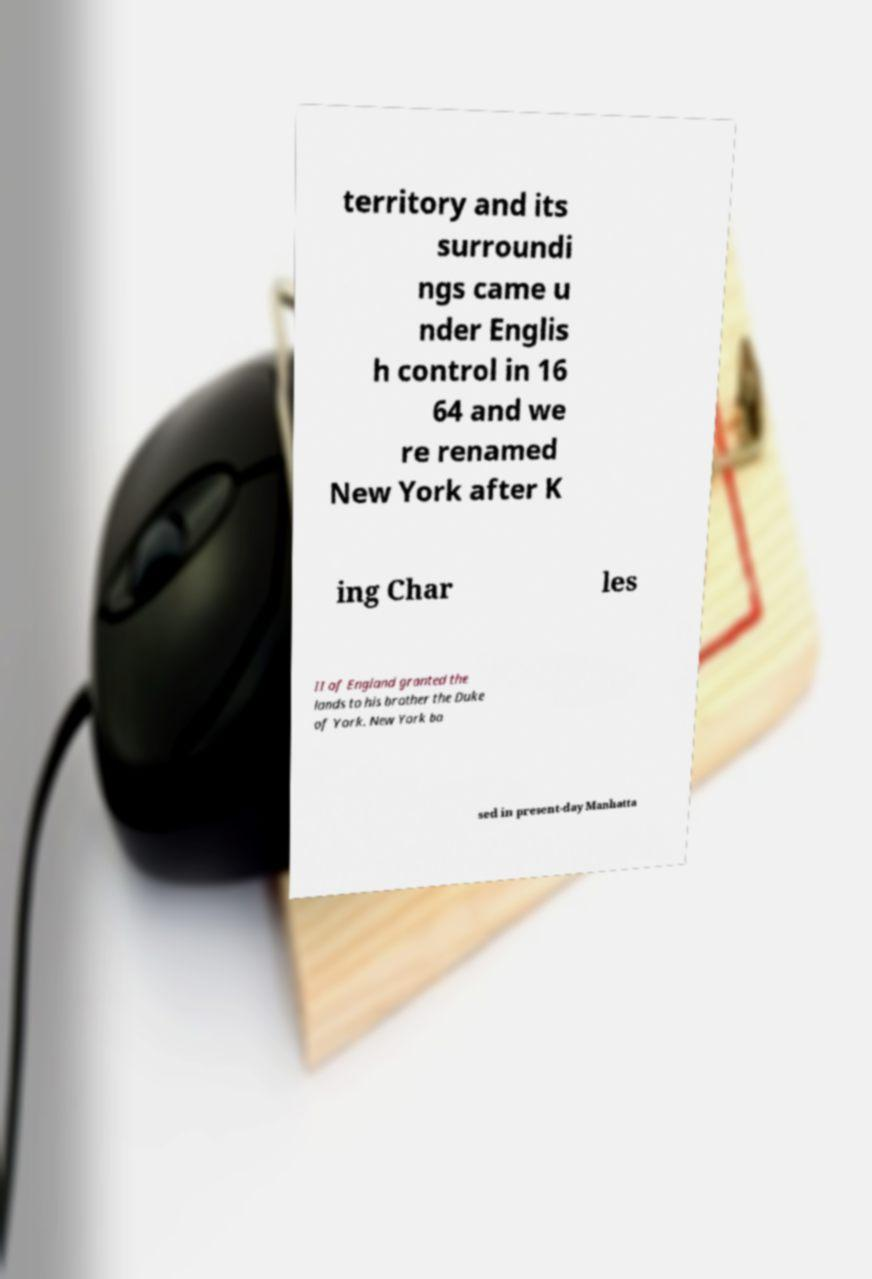Can you accurately transcribe the text from the provided image for me? territory and its surroundi ngs came u nder Englis h control in 16 64 and we re renamed New York after K ing Char les II of England granted the lands to his brother the Duke of York. New York ba sed in present-day Manhatta 